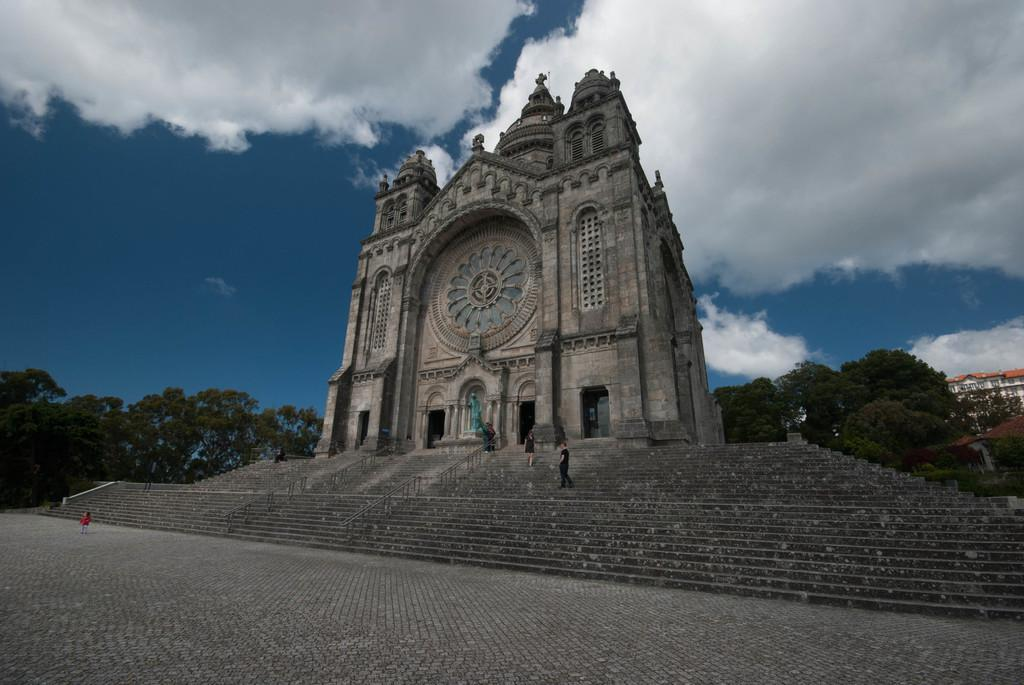What can be seen in the image that people use to move between different levels? There are steps in the image that people use to move between different levels. Who or what is present in the image? There are people in the image. What type of structure is visible in the image? There is a building in the image. What type of vegetation can be seen in the background of the image? There are trees in the background of the image. How would you describe the weather based on the image? The sky is cloudy in the image, which suggests a partly cloudy or overcast day. Can you tell me what the writer is doing with the cat and receipt in the image? There is no writer, cat, or receipt present in the image. 